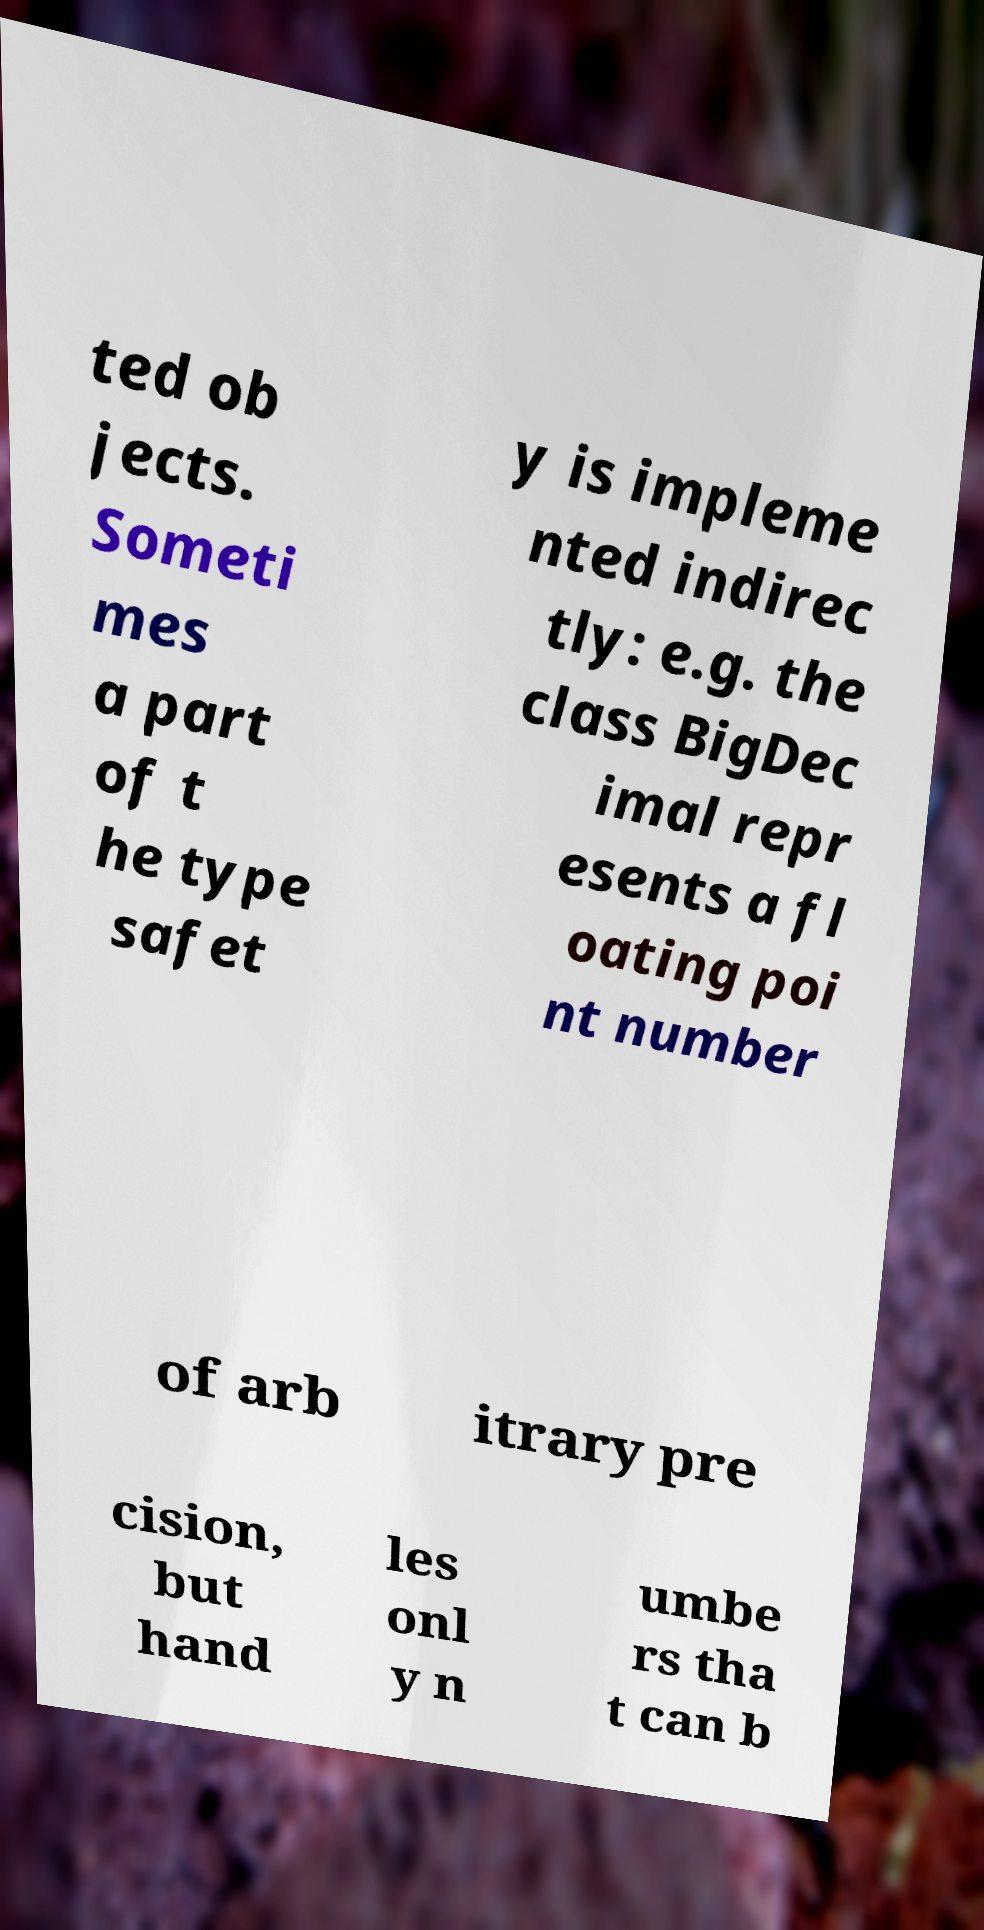Can you accurately transcribe the text from the provided image for me? ted ob jects. Someti mes a part of t he type safet y is impleme nted indirec tly: e.g. the class BigDec imal repr esents a fl oating poi nt number of arb itrary pre cision, but hand les onl y n umbe rs tha t can b 